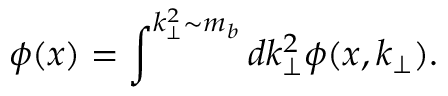<formula> <loc_0><loc_0><loc_500><loc_500>\phi ( x ) = \int ^ { k _ { \perp } ^ { 2 } \sim m _ { b } } d k _ { \perp } ^ { 2 } \phi ( x , k _ { \perp } ) .</formula> 